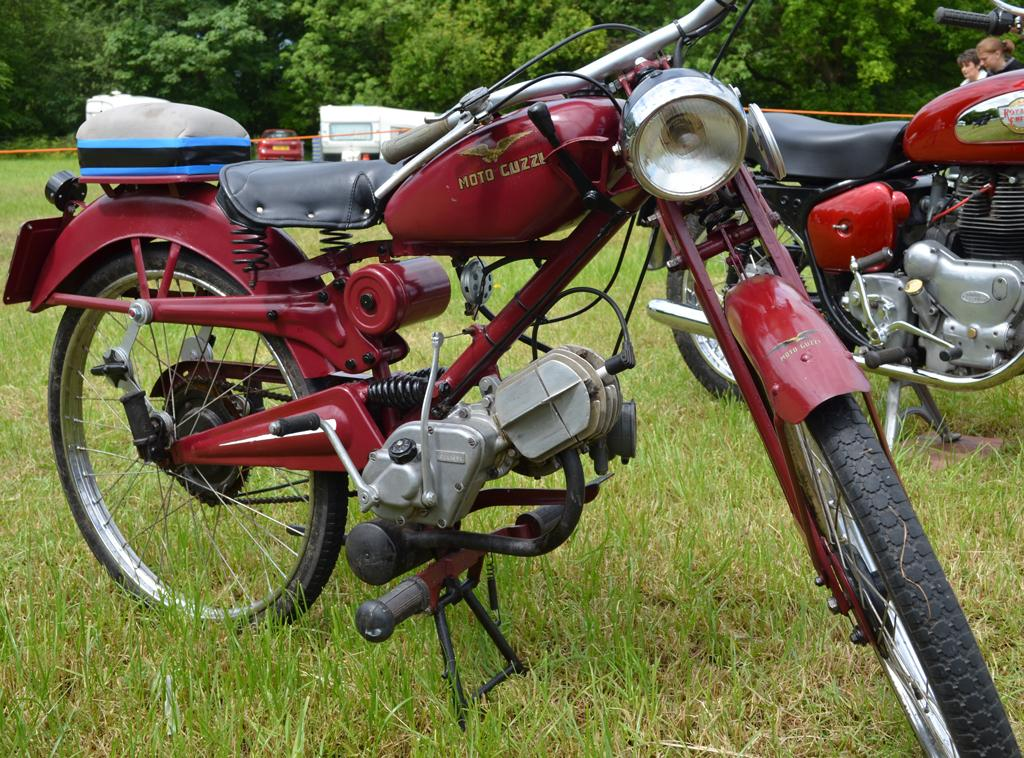What objects are on the grass in the image? There are bikes on the grass in the image. What can be seen in the background of the image? There are vehicles, people, and trees in the background of the image. What type of stitch is used to create the plants in the image? There are no plants or stitching present in the image; it features bikes on the grass and various elements in the background. 